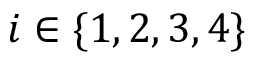<formula> <loc_0><loc_0><loc_500><loc_500>i \in \{ 1 , 2 , 3 , 4 \}</formula> 